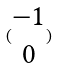Convert formula to latex. <formula><loc_0><loc_0><loc_500><loc_500>( \begin{matrix} - 1 \\ 0 \end{matrix} )</formula> 